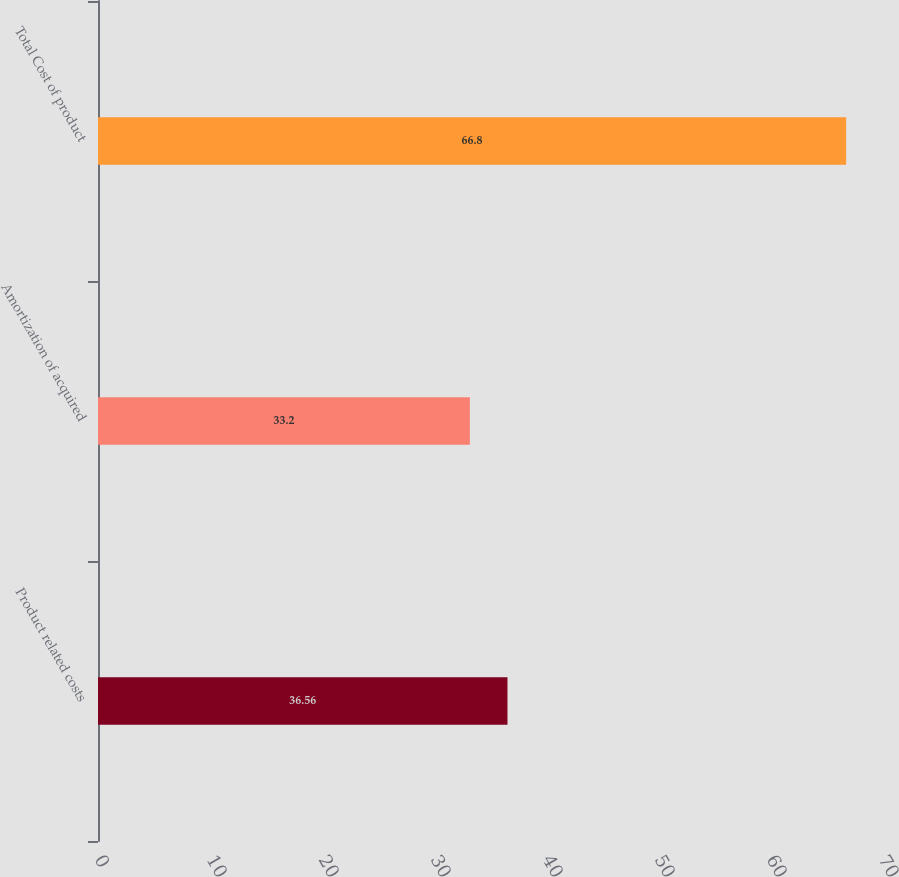Convert chart. <chart><loc_0><loc_0><loc_500><loc_500><bar_chart><fcel>Product related costs<fcel>Amortization of acquired<fcel>Total Cost of product<nl><fcel>36.56<fcel>33.2<fcel>66.8<nl></chart> 